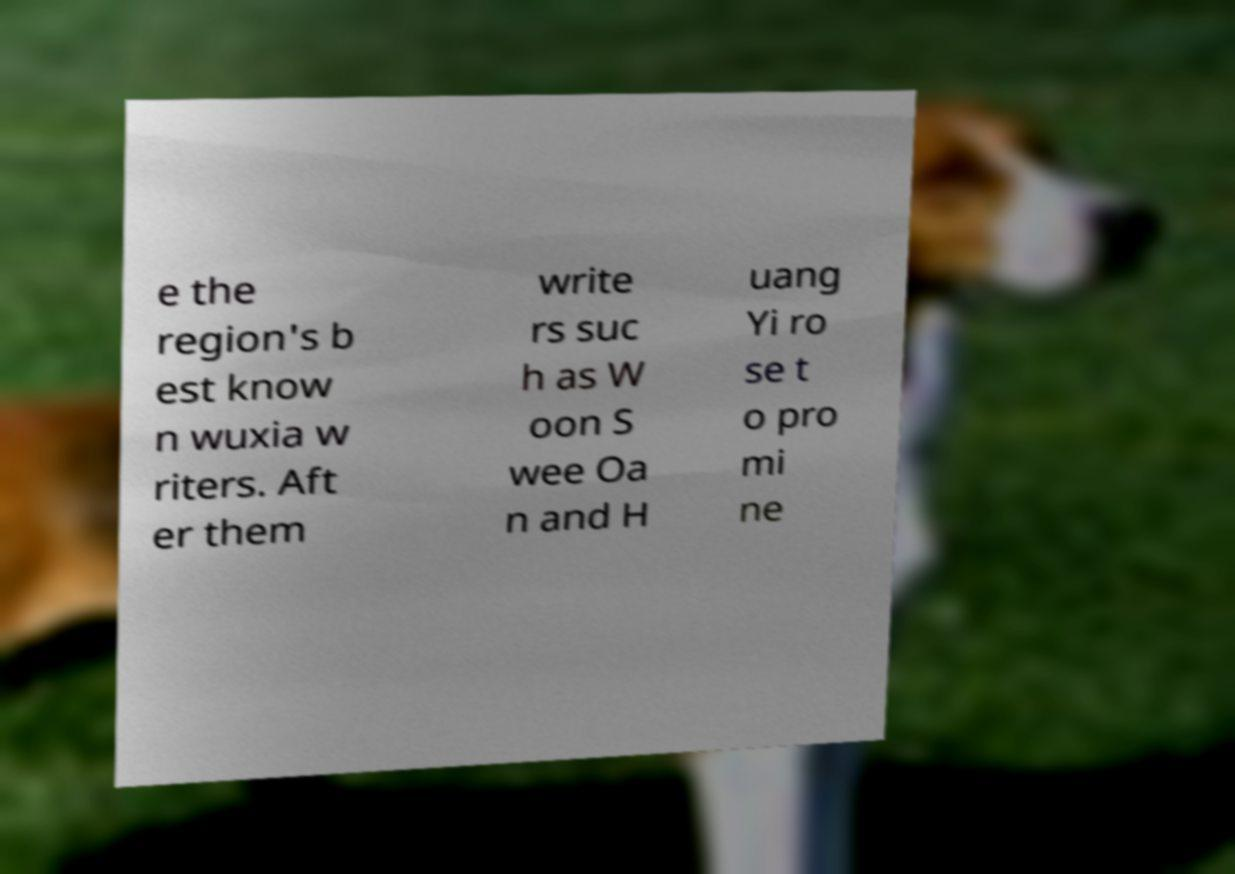There's text embedded in this image that I need extracted. Can you transcribe it verbatim? e the region's b est know n wuxia w riters. Aft er them write rs suc h as W oon S wee Oa n and H uang Yi ro se t o pro mi ne 